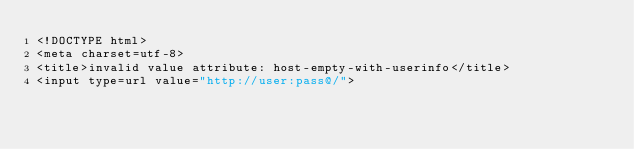Convert code to text. <code><loc_0><loc_0><loc_500><loc_500><_HTML_><!DOCTYPE html>
<meta charset=utf-8>
<title>invalid value attribute: host-empty-with-userinfo</title>
<input type=url value="http://user:pass@/">
</code> 